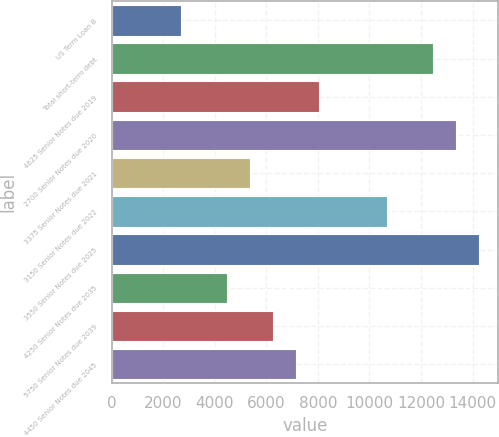<chart> <loc_0><loc_0><loc_500><loc_500><bar_chart><fcel>US Term Loan B<fcel>Total short-term debt<fcel>4625 Senior Notes due 2019<fcel>2700 Senior Notes due 2020<fcel>3375 Senior Notes due 2021<fcel>3150 Senior Notes due 2022<fcel>3550 Senior Notes due 2025<fcel>4250 Senior Notes due 2035<fcel>5750 Senior Notes due 2039<fcel>4450 Senior Notes due 2045<nl><fcel>2678.12<fcel>12482.9<fcel>8026.16<fcel>13374.2<fcel>5352.14<fcel>10700.2<fcel>14265.5<fcel>4460.8<fcel>6243.48<fcel>7134.82<nl></chart> 